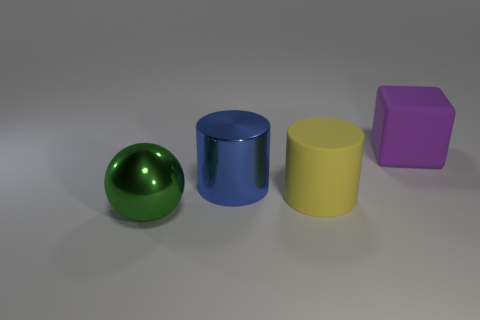There is a metallic object that is in front of the blue metal object; is it the same size as the large yellow object? While it's clear that the metallic green sphere in front of the blue cylinder shares a smooth and shiny surface with the other objects, assessing size can be tricky without direct comparison or measurement. Despite appearances, the green sphere is not the same size as the yellow cylinder—its circular shape suggests it might be smaller, both in height and diameter. 